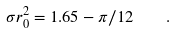<formula> <loc_0><loc_0><loc_500><loc_500>\sigma r _ { 0 } ^ { 2 } = 1 . 6 5 - \pi / 1 2 \quad .</formula> 